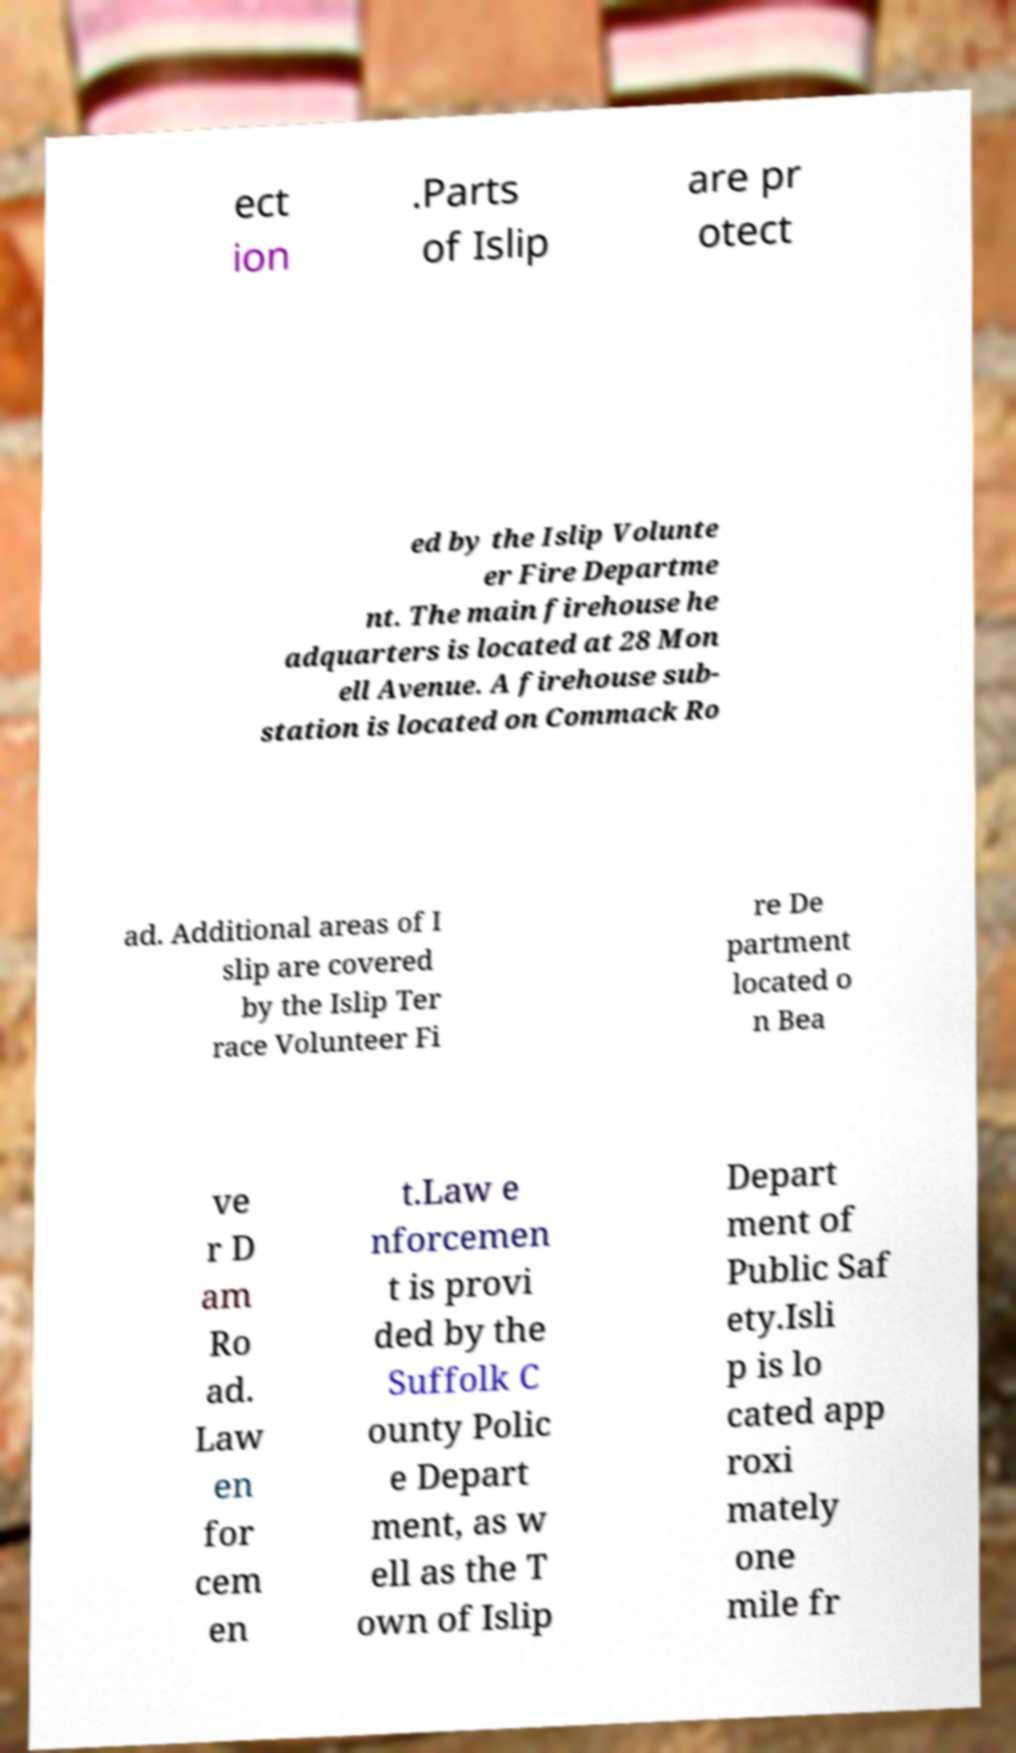I need the written content from this picture converted into text. Can you do that? ect ion .Parts of Islip are pr otect ed by the Islip Volunte er Fire Departme nt. The main firehouse he adquarters is located at 28 Mon ell Avenue. A firehouse sub- station is located on Commack Ro ad. Additional areas of I slip are covered by the Islip Ter race Volunteer Fi re De partment located o n Bea ve r D am Ro ad. Law en for cem en t.Law e nforcemen t is provi ded by the Suffolk C ounty Polic e Depart ment, as w ell as the T own of Islip Depart ment of Public Saf ety.Isli p is lo cated app roxi mately one mile fr 